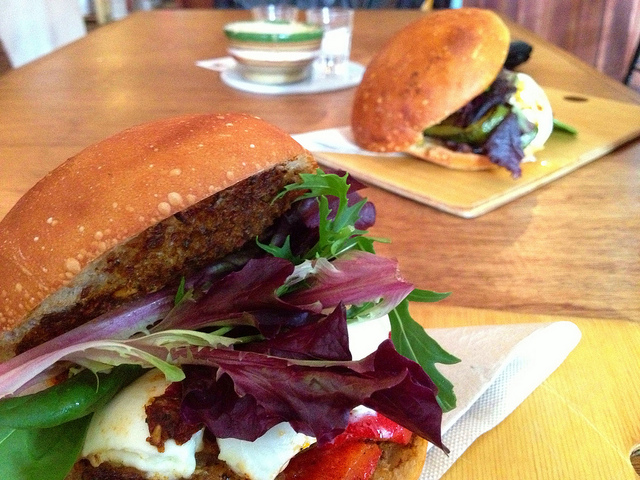What ingredients would you suggest to someone wanting to recreate these sandwiches at home? To recreate these sandwiches, I'd recommend getting some fresh, crusty buns and a selection of mixed greens. For the veggie sandwich, find a quality veggie burger patty and perhaps some feta cheese and roasted red peppers. For the grilled vegetable sandwich, you'd want to slice and grill some eggplant and zucchini, top it with a slice of provolone or mozzarella cheese, and add a spread of mayonnaise or aioli to the bun. 